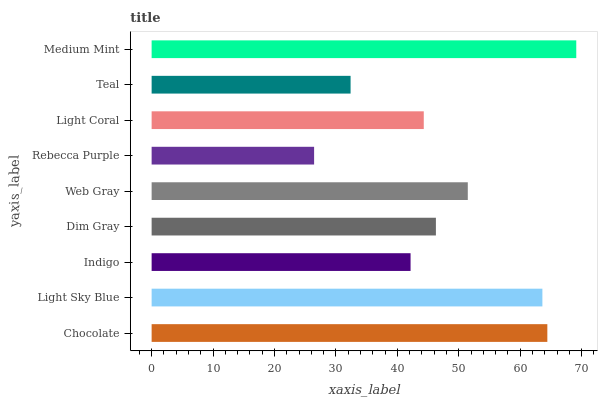Is Rebecca Purple the minimum?
Answer yes or no. Yes. Is Medium Mint the maximum?
Answer yes or no. Yes. Is Light Sky Blue the minimum?
Answer yes or no. No. Is Light Sky Blue the maximum?
Answer yes or no. No. Is Chocolate greater than Light Sky Blue?
Answer yes or no. Yes. Is Light Sky Blue less than Chocolate?
Answer yes or no. Yes. Is Light Sky Blue greater than Chocolate?
Answer yes or no. No. Is Chocolate less than Light Sky Blue?
Answer yes or no. No. Is Dim Gray the high median?
Answer yes or no. Yes. Is Dim Gray the low median?
Answer yes or no. Yes. Is Web Gray the high median?
Answer yes or no. No. Is Light Sky Blue the low median?
Answer yes or no. No. 